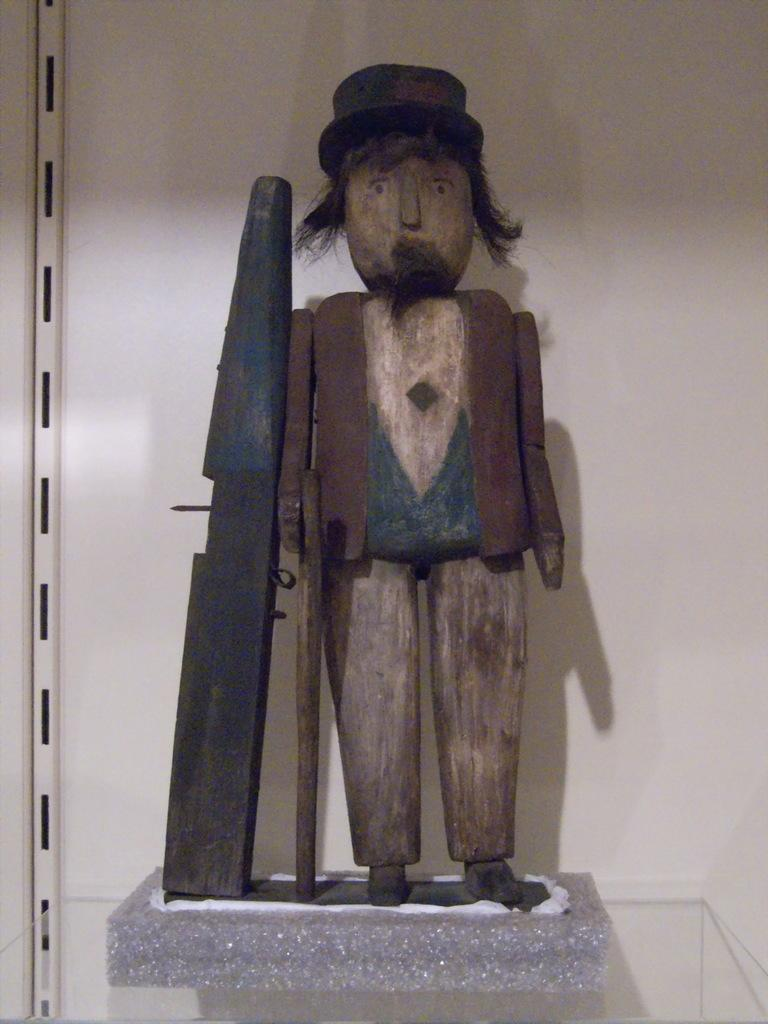Where was the image taken? The image was taken indoors. What can be seen in the background of the image? There is a wall in the background of the image. What object is on the shelf in the middle of the image? There is a wooden toy of a man on the shelf in the middle of the image. How many eyes does the wooden toy have? The wooden toy is not a living creature and does not have eyes. 